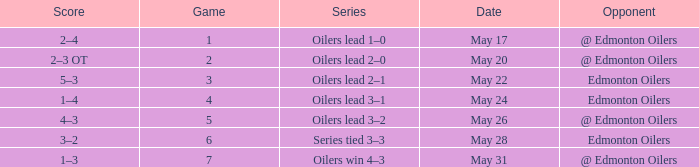Opponent of @ edmonton oilers, and a Game larger than 1, and a Series of oilers lead 3–2 had what score? 4–3. 